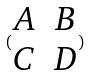<formula> <loc_0><loc_0><loc_500><loc_500>( \begin{matrix} A & B \\ C & D \end{matrix} )</formula> 